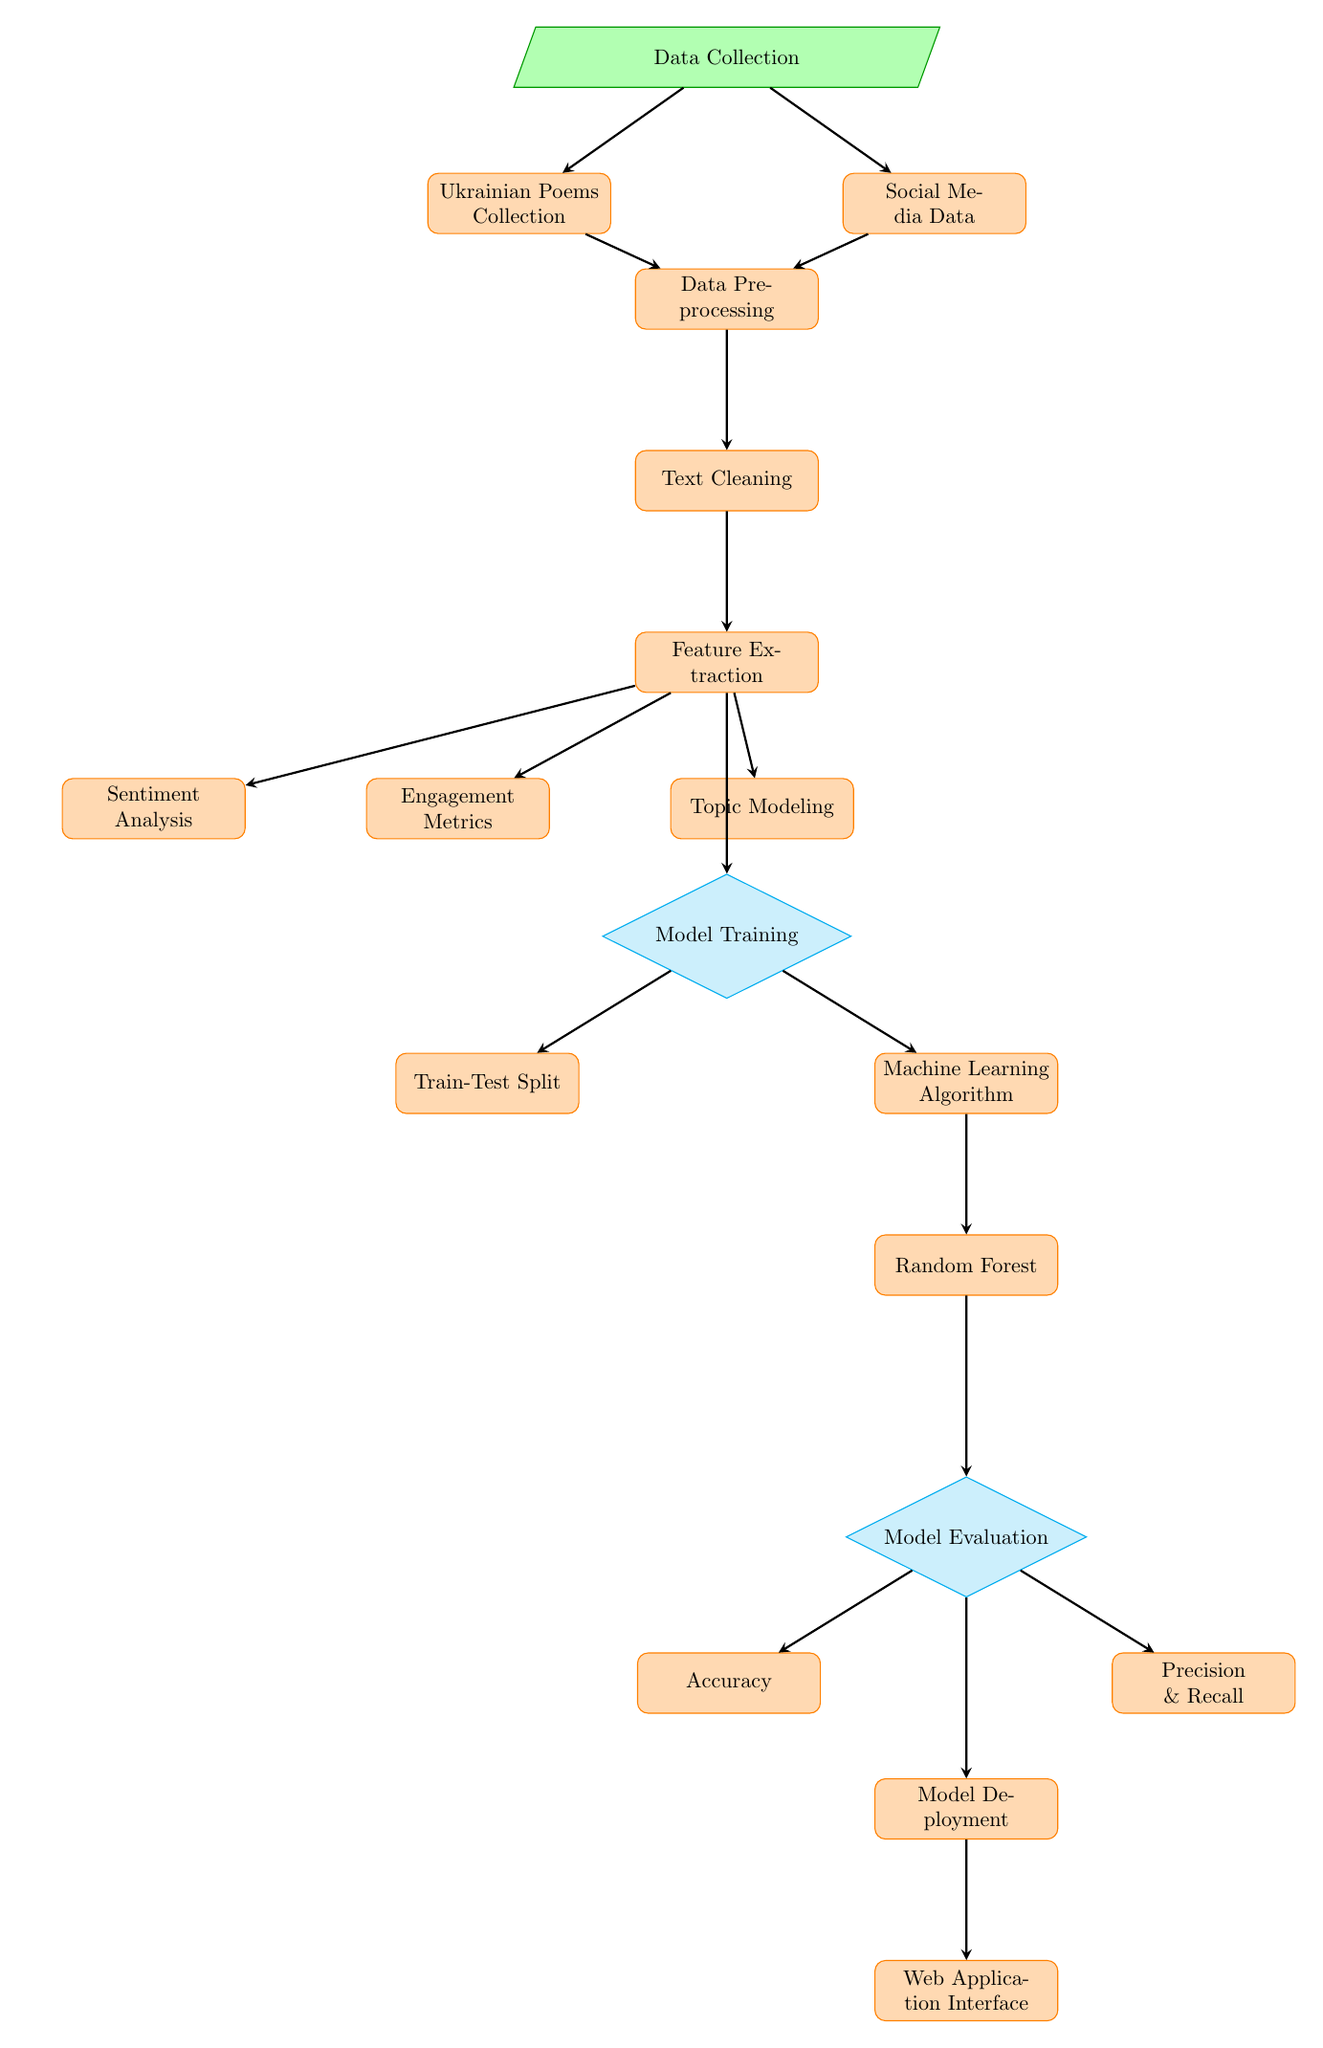What is the first step in this process? The diagram starts with "Data Collection" at the top, indicating that collecting data is the initial step before any processing or analysis occurs.
Answer: Data Collection How many main processes are listed in the diagram? Counting all the processes visually displayed under each category (preprocessing, feature extraction, model training, and evaluation and deployment), there are six main processes identified.
Answer: Six What type of analysis is performed after preprocessing? Following the "Data Preprocessing" step, the next stage is called "Feature Extraction," which involves extracting important features from the data collected from poems and social media.
Answer: Feature Extraction Which node represents the method used for Model Training? The node labeled "Machine Learning Algorithm" signifies the approach taken for model training, which further leads to the "Random Forest" method.
Answer: Machine Learning Algorithm What is the output of the model evaluation process? After the model training process, the output is evaluated through "Model Evaluation," which checks metrics such as accuracy and precision, as indicated in the diagram below this step.
Answer: Model Evaluation Which aspects do the "Engagement Metrics," "Sentiment Analysis," and "Topic Modeling" pertain to? These three processes are part of the "Feature Extraction" stage, and they specifically deal with analyzing different features of the poems based on social media information.
Answer: Feature Extraction How many metrics are used for model evaluation? The evaluation stage includes three metrics that assess the model's performance: Accuracy, Precision, and Recall. Thus, the total count of these metrics is three.
Answer: Three What is the final output of the diagram's workflow? The entire process culminates in the "Web Application Interface," which is the final output that users would interact with following the model's deployment.
Answer: Web Application Interface Which category includes the "Random Forest" method? The "Random Forest" method is included under the "Model Training" category, highlighting its role as a specific machine learning algorithm in the training phase.
Answer: Model Training 